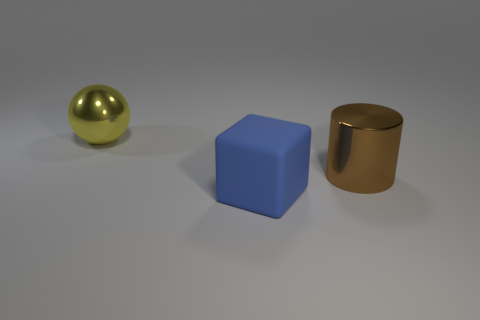Add 3 tiny cyan metallic cubes. How many objects exist? 6 Subtract all cylinders. How many objects are left? 2 Add 3 blue things. How many blue things are left? 4 Add 3 big things. How many big things exist? 6 Subtract 0 purple cylinders. How many objects are left? 3 Subtract all small brown matte spheres. Subtract all large brown objects. How many objects are left? 2 